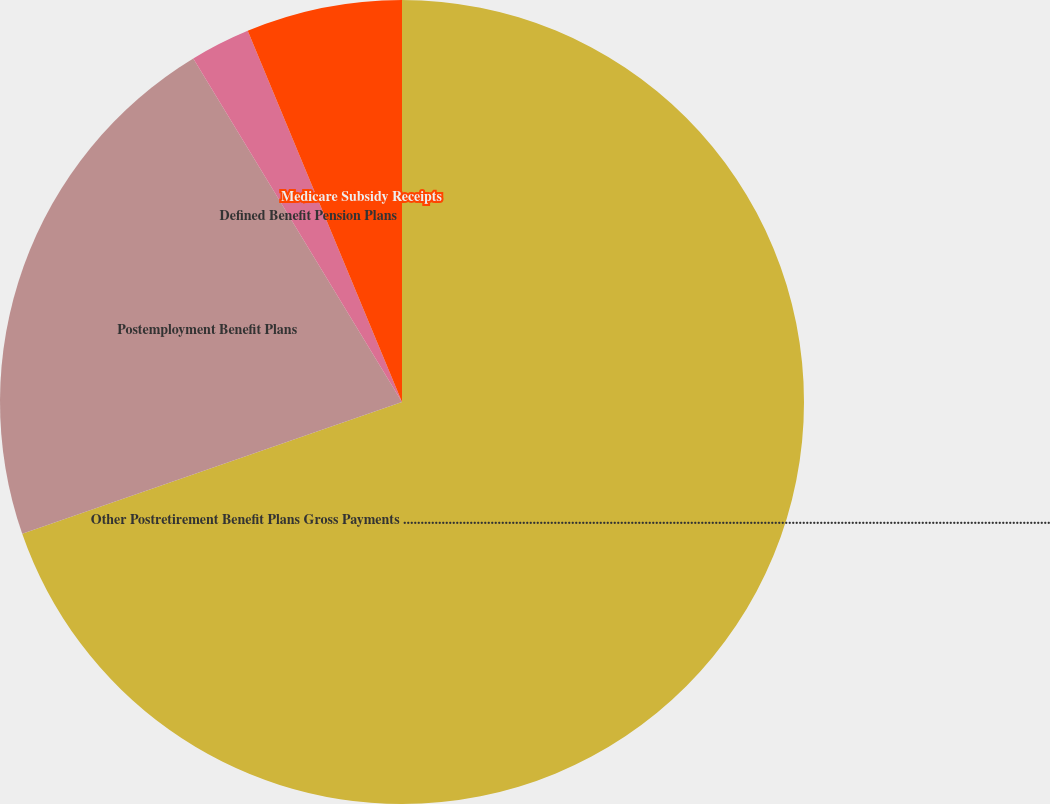<chart> <loc_0><loc_0><loc_500><loc_500><pie_chart><fcel>Other Postretirement Benefit Plans Gross Payments .........................................................................................................................................................................................<fcel>Postemployment Benefit Plans<fcel>Defined Benefit Pension Plans<fcel>Medicare Subsidy Receipts<nl><fcel>69.69%<fcel>21.63%<fcel>2.42%<fcel>6.27%<nl></chart> 